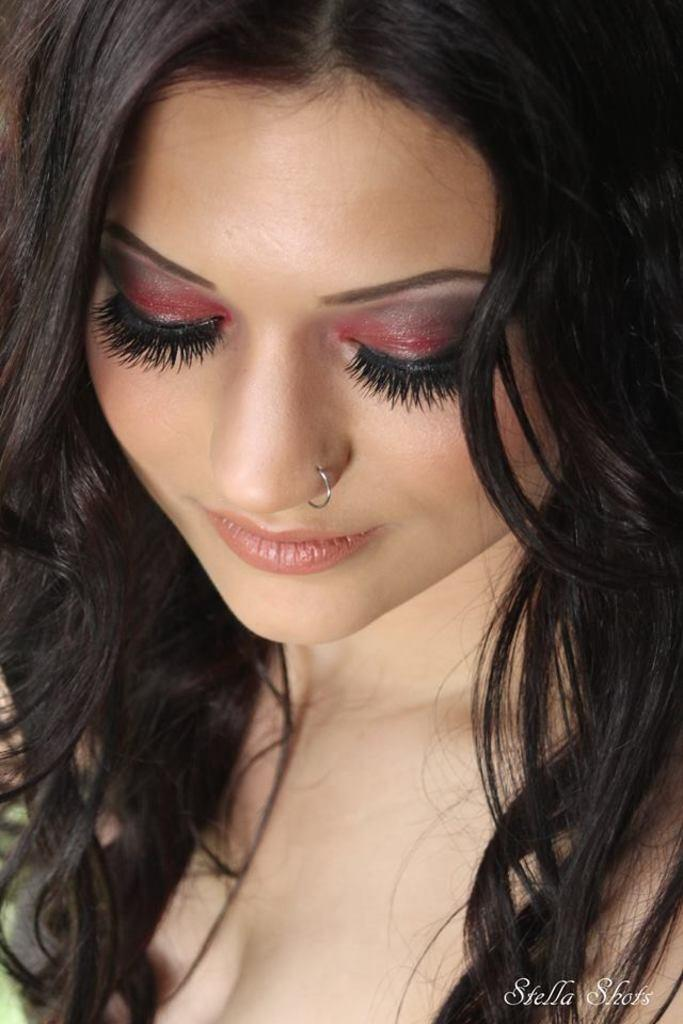Who is the main subject in the picture? There is a girl in the picture. What is the girl doing in the picture? The girl is posing for the photo. What expression does the girl have in the picture? The girl is smiling. What type of scissors can be seen in the girl's hand in the picture? There are no scissors present in the picture. How many chickens are visible in the background of the picture? There are no chickens present in the picture. 